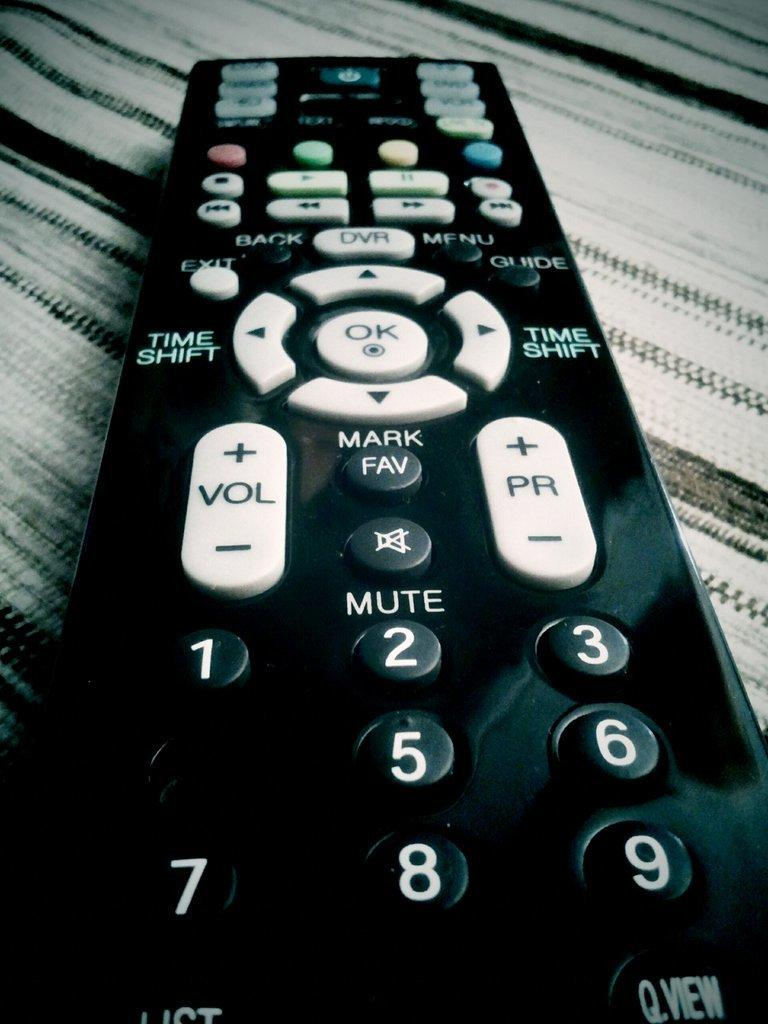<image>
Write a terse but informative summary of the picture. A remote control which has the words Time Shift on it twice. 